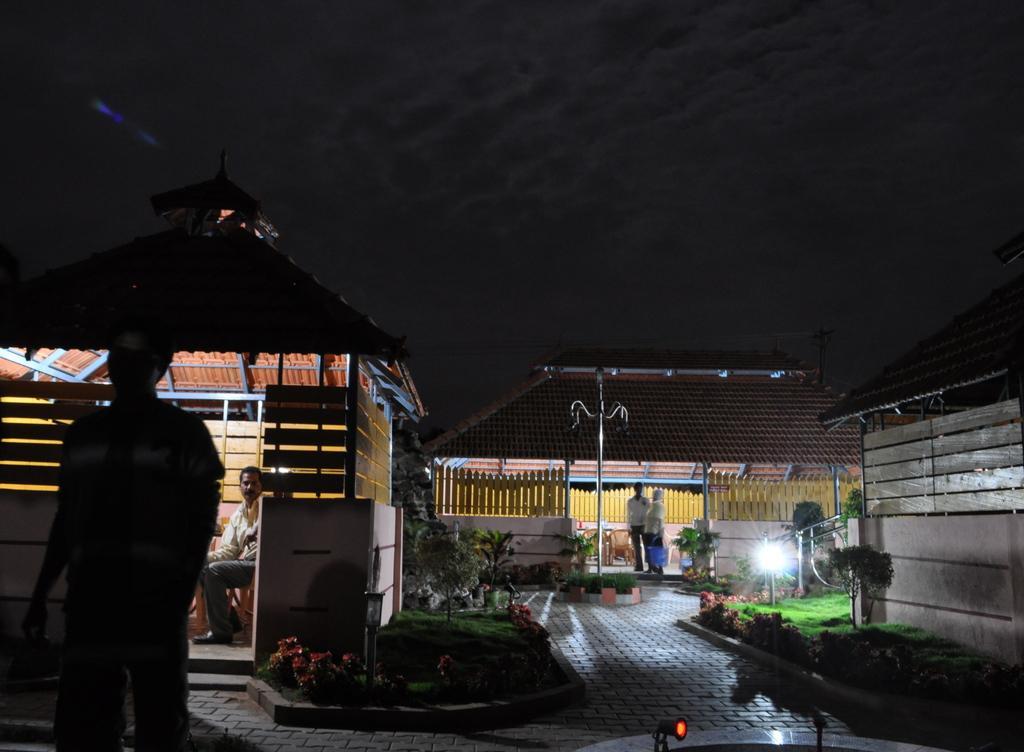How would you summarize this image in a sentence or two? On the left side, there is a person standing and there is a person sitting in a shelter. On the right side, there is a road, there is a garden and there is a light. In the background, there are two persons standing on a floor of a shelter. And the background is dark in color. 